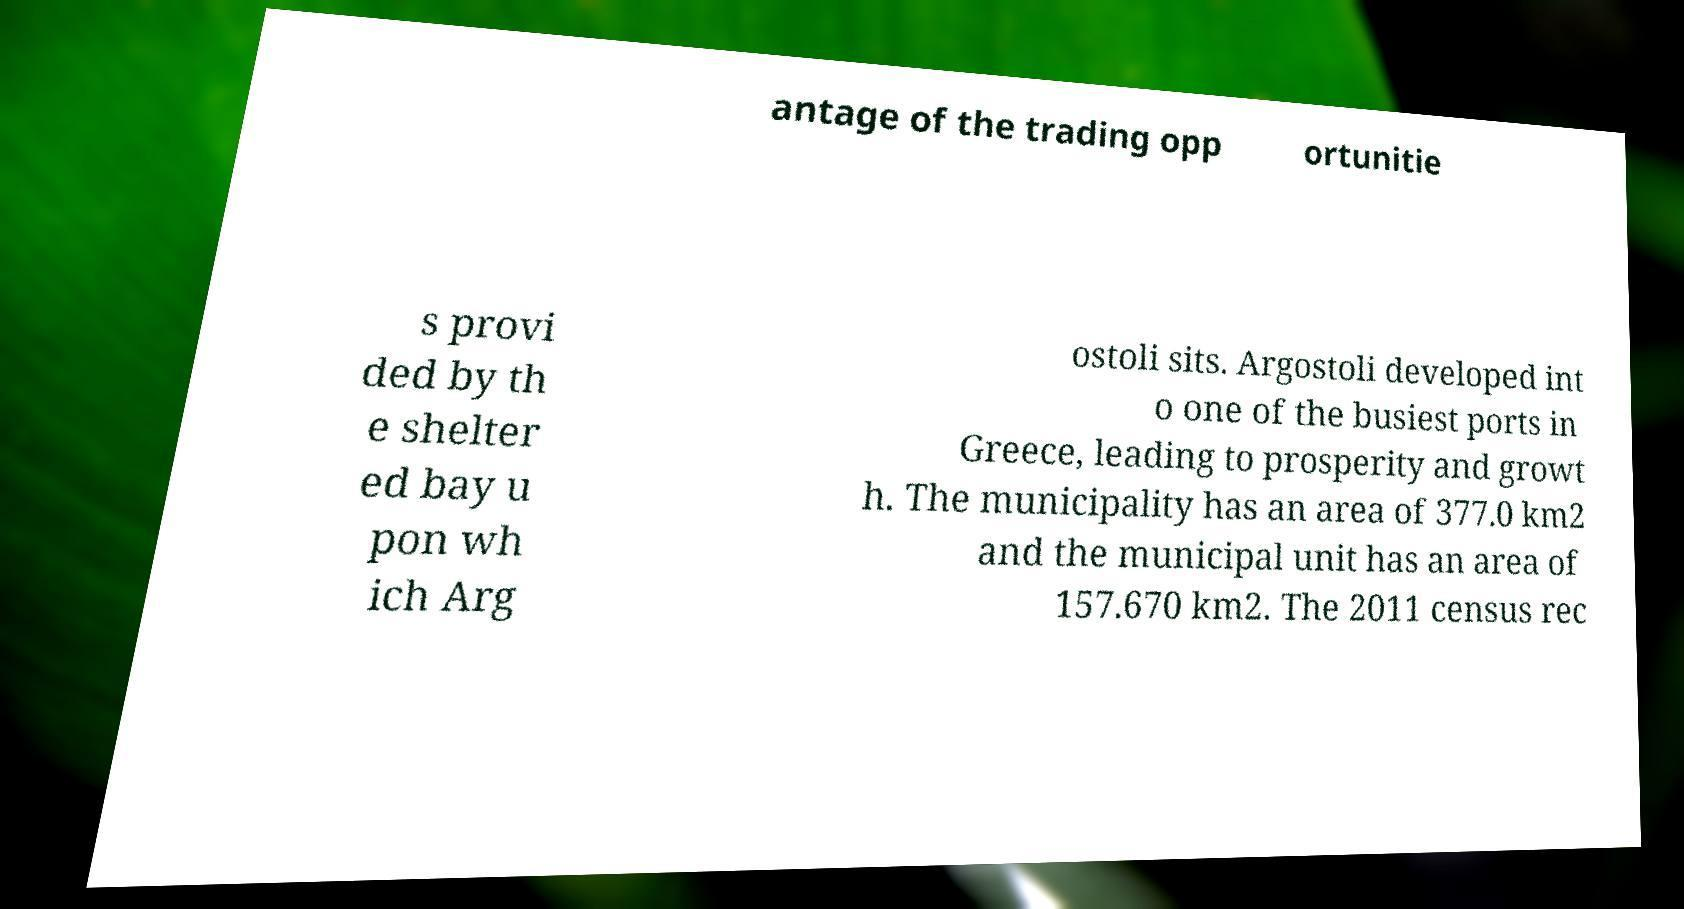Can you read and provide the text displayed in the image?This photo seems to have some interesting text. Can you extract and type it out for me? antage of the trading opp ortunitie s provi ded by th e shelter ed bay u pon wh ich Arg ostoli sits. Argostoli developed int o one of the busiest ports in Greece, leading to prosperity and growt h. The municipality has an area of 377.0 km2 and the municipal unit has an area of 157.670 km2. The 2011 census rec 